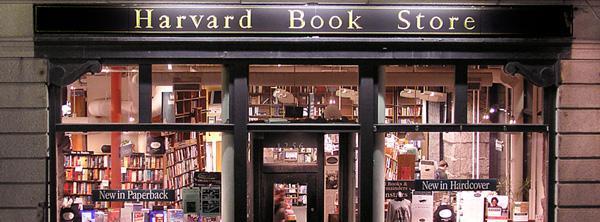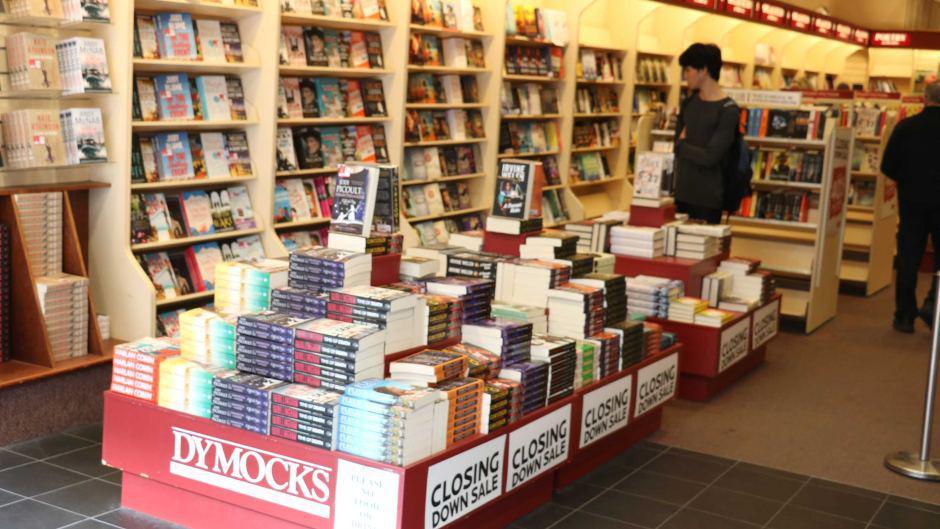The first image is the image on the left, the second image is the image on the right. For the images displayed, is the sentence "There are at least two people inside the store in the image on the right." factually correct? Answer yes or no. Yes. 